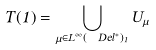Convert formula to latex. <formula><loc_0><loc_0><loc_500><loc_500>T ( 1 ) = \bigcup _ { \mu \in L ^ { \infty } ( \ D e l ^ { * } ) _ { 1 } } U _ { \mu }</formula> 